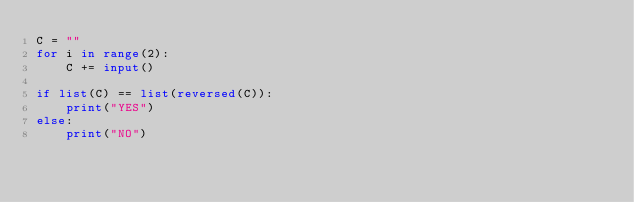<code> <loc_0><loc_0><loc_500><loc_500><_Python_>C = ""
for i in range(2):
    C += input()
    
if list(C) == list(reversed(C)):
    print("YES")
else:
    print("NO")</code> 